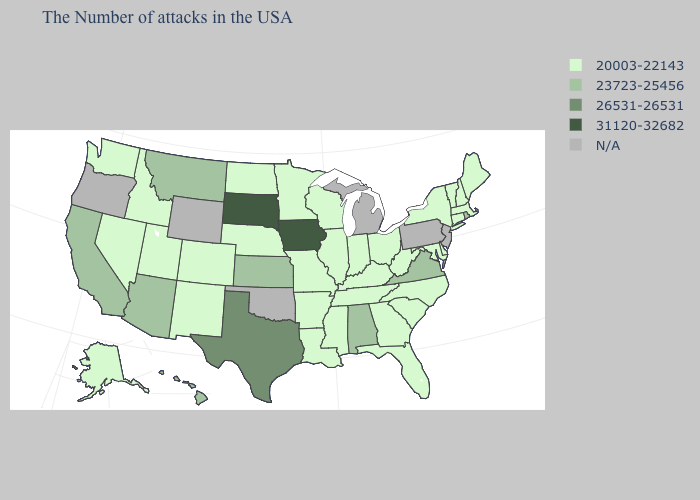Among the states that border North Carolina , which have the lowest value?
Answer briefly. South Carolina, Georgia, Tennessee. Name the states that have a value in the range 31120-32682?
Write a very short answer. Iowa, South Dakota. Name the states that have a value in the range N/A?
Quick response, please. New Jersey, Pennsylvania, Michigan, Oklahoma, Wyoming, Oregon. Name the states that have a value in the range 23723-25456?
Short answer required. Rhode Island, Virginia, Alabama, Kansas, Montana, Arizona, California, Hawaii. What is the value of Delaware?
Answer briefly. 20003-22143. What is the value of West Virginia?
Give a very brief answer. 20003-22143. What is the value of Kentucky?
Answer briefly. 20003-22143. Name the states that have a value in the range 26531-26531?
Give a very brief answer. Texas. Name the states that have a value in the range 26531-26531?
Answer briefly. Texas. What is the value of Hawaii?
Keep it brief. 23723-25456. Among the states that border Minnesota , does South Dakota have the lowest value?
Be succinct. No. Does South Dakota have the lowest value in the MidWest?
Concise answer only. No. What is the highest value in the USA?
Quick response, please. 31120-32682. Does the map have missing data?
Concise answer only. Yes. What is the value of Indiana?
Write a very short answer. 20003-22143. 